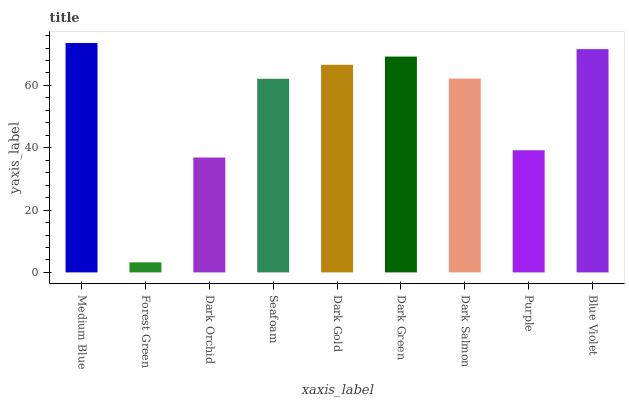Is Dark Orchid the minimum?
Answer yes or no. No. Is Dark Orchid the maximum?
Answer yes or no. No. Is Dark Orchid greater than Forest Green?
Answer yes or no. Yes. Is Forest Green less than Dark Orchid?
Answer yes or no. Yes. Is Forest Green greater than Dark Orchid?
Answer yes or no. No. Is Dark Orchid less than Forest Green?
Answer yes or no. No. Is Dark Salmon the high median?
Answer yes or no. Yes. Is Dark Salmon the low median?
Answer yes or no. Yes. Is Purple the high median?
Answer yes or no. No. Is Forest Green the low median?
Answer yes or no. No. 